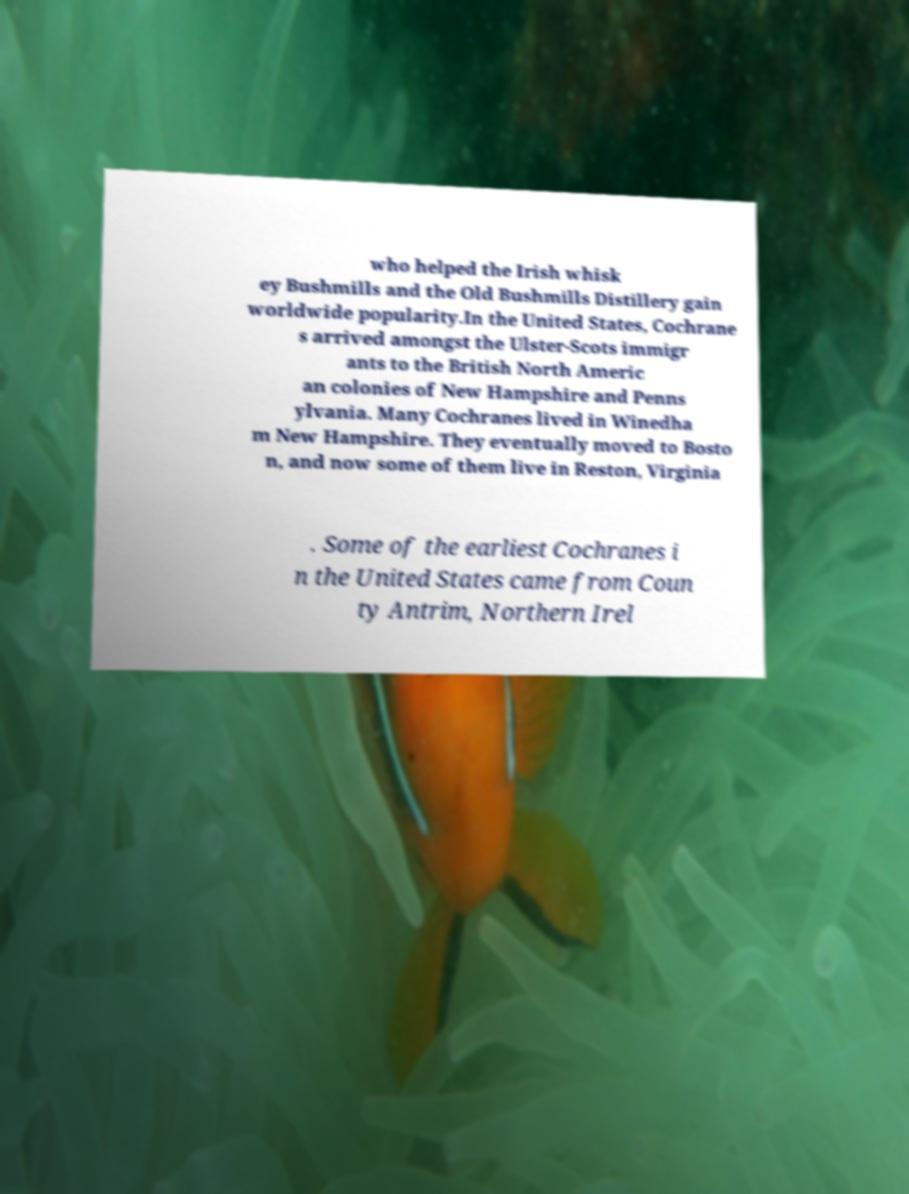Please identify and transcribe the text found in this image. who helped the Irish whisk ey Bushmills and the Old Bushmills Distillery gain worldwide popularity.In the United States, Cochrane s arrived amongst the Ulster-Scots immigr ants to the British North Americ an colonies of New Hampshire and Penns ylvania. Many Cochranes lived in Winedha m New Hampshire. They eventually moved to Bosto n, and now some of them live in Reston, Virginia . Some of the earliest Cochranes i n the United States came from Coun ty Antrim, Northern Irel 